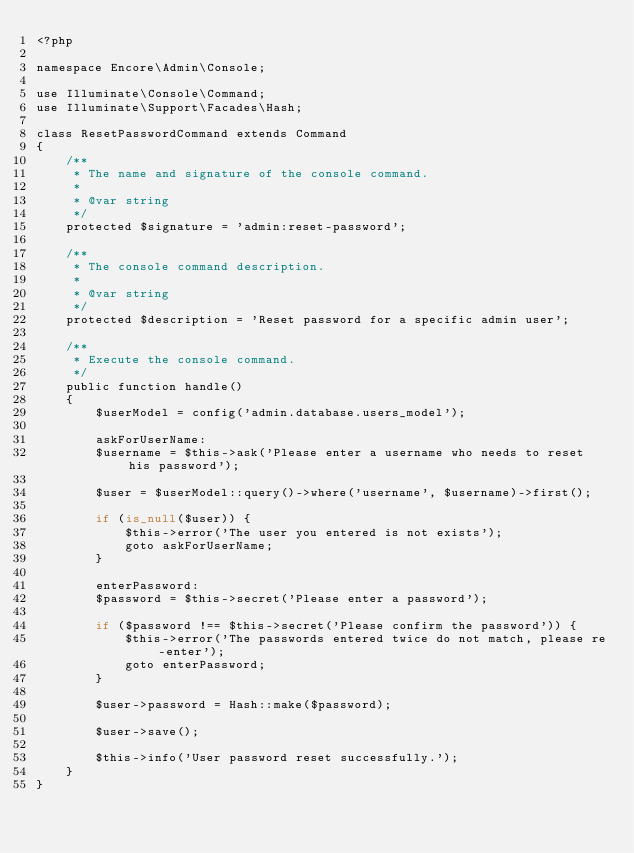<code> <loc_0><loc_0><loc_500><loc_500><_PHP_><?php

namespace Encore\Admin\Console;

use Illuminate\Console\Command;
use Illuminate\Support\Facades\Hash;

class ResetPasswordCommand extends Command
{
    /**
     * The name and signature of the console command.
     *
     * @var string
     */
    protected $signature = 'admin:reset-password';

    /**
     * The console command description.
     *
     * @var string
     */
    protected $description = 'Reset password for a specific admin user';

    /**
     * Execute the console command.
     */
    public function handle()
    {
        $userModel = config('admin.database.users_model');

        askForUserName:
        $username = $this->ask('Please enter a username who needs to reset his password');

        $user = $userModel::query()->where('username', $username)->first();

        if (is_null($user)) {
            $this->error('The user you entered is not exists');
            goto askForUserName;
        }

        enterPassword:
        $password = $this->secret('Please enter a password');

        if ($password !== $this->secret('Please confirm the password')) {
            $this->error('The passwords entered twice do not match, please re-enter');
            goto enterPassword;
        }

        $user->password = Hash::make($password);

        $user->save();

        $this->info('User password reset successfully.');
    }
}
</code> 